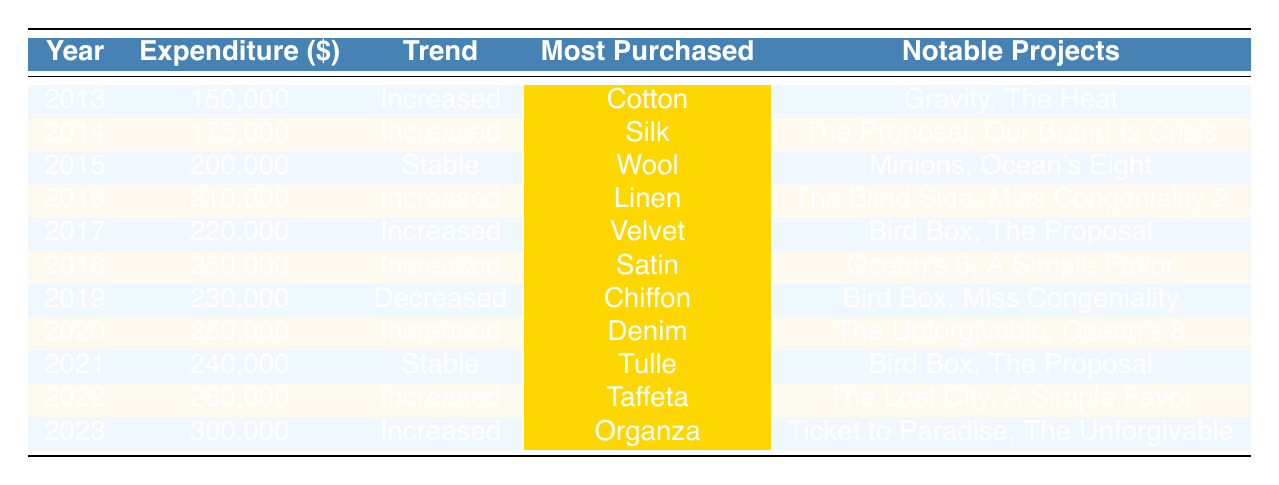What was the total expenditure in 2020? The table shows the total expenditure for 2020 is listed as 260,000.
Answer: 260,000 Which fabric was most purchased in 2018? The most purchased fabric for 2018 is highlighted in the table as Satin.
Answer: Satin How many years showed an 'increased' trend? Counting the years with 'increased' trends: 2013, 2014, 2016, 2017, 2018, 2020, 2022, and 2023 gives us 8 years in total.
Answer: 8 Was there a year when the expenditure decreased? Looking at the table, the only year with a 'decreased' trend is 2019.
Answer: Yes What was the difference in total expenditure between 2019 and 2021? The total expenditure in 2019 is 230,000, and in 2021 it's 240,000. The difference is 240,000 - 230,000 = 10,000.
Answer: 10,000 Which notable project is associated with the most purchased fabric in 2022? In 2022, the most purchased fabric is Taffeta, and it is associated with "The Lost City" among others.
Answer: The Lost City What was the average total expenditure from 2013 to 2023? To calculate the average, we sum the expenditures (150,000 + 175,000 + 200,000 + 210,000 + 220,000 + 250,000 + 240,000 + 280,000 + 300,000 = 1,785,000) and divide by the number of years (9). The average is 1,785,000 / 9 ≈ 198,333.
Answer: 198,333 In which years did 'Linen' get highlighted as the most purchased fabric? 'Linen' was highlighted in the year 2016 as the most purchased fabric.
Answer: 2016 Which fabric has continually been associated with Sandra Bullock's known projects in 2020? The fabric highlighted for 2020 is Denim, which is associated with "The Unforgivable" and "Ocean's 8."
Answer: Denim Is it true that the same fabric was the most purchased in more than one year? Yes, the fabric 'Cotton' was most purchased in 2013 and 'Silk' in 2014.
Answer: Yes 